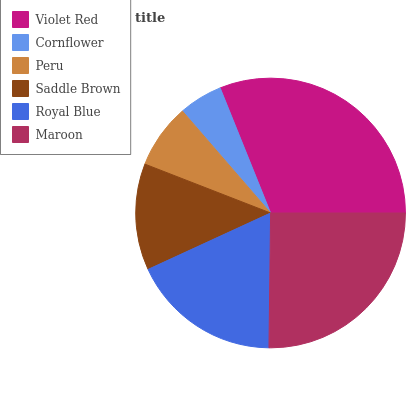Is Cornflower the minimum?
Answer yes or no. Yes. Is Violet Red the maximum?
Answer yes or no. Yes. Is Peru the minimum?
Answer yes or no. No. Is Peru the maximum?
Answer yes or no. No. Is Peru greater than Cornflower?
Answer yes or no. Yes. Is Cornflower less than Peru?
Answer yes or no. Yes. Is Cornflower greater than Peru?
Answer yes or no. No. Is Peru less than Cornflower?
Answer yes or no. No. Is Royal Blue the high median?
Answer yes or no. Yes. Is Saddle Brown the low median?
Answer yes or no. Yes. Is Violet Red the high median?
Answer yes or no. No. Is Royal Blue the low median?
Answer yes or no. No. 